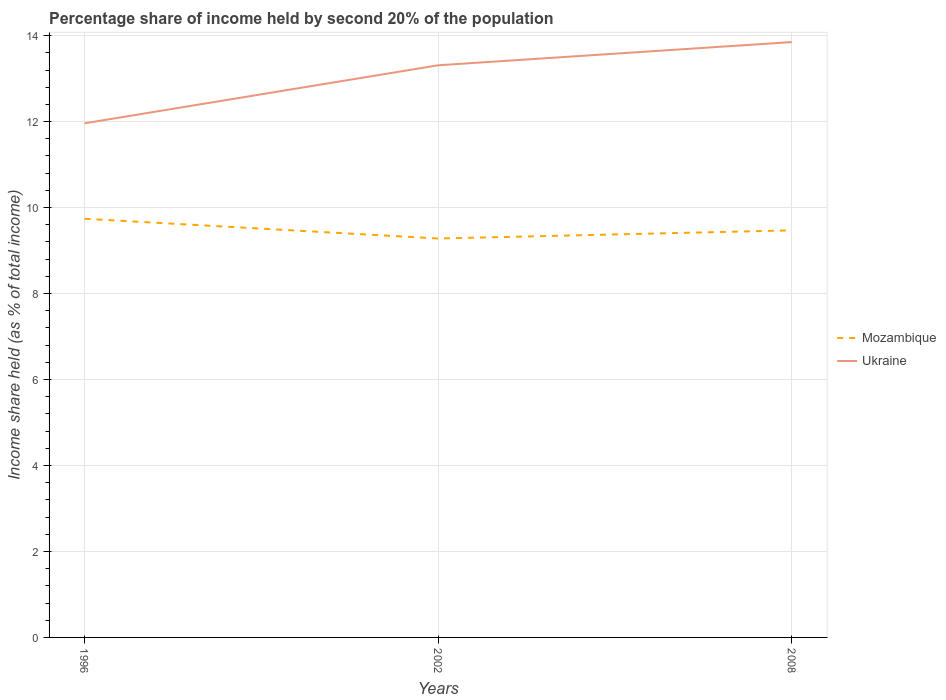How many different coloured lines are there?
Give a very brief answer. 2. Does the line corresponding to Ukraine intersect with the line corresponding to Mozambique?
Give a very brief answer. No. Is the number of lines equal to the number of legend labels?
Your response must be concise. Yes. Across all years, what is the maximum share of income held by second 20% of the population in Ukraine?
Offer a very short reply. 11.96. What is the total share of income held by second 20% of the population in Mozambique in the graph?
Keep it short and to the point. 0.46. What is the difference between the highest and the second highest share of income held by second 20% of the population in Mozambique?
Give a very brief answer. 0.46. How many lines are there?
Ensure brevity in your answer.  2. What is the difference between two consecutive major ticks on the Y-axis?
Your answer should be very brief. 2. Does the graph contain grids?
Offer a terse response. Yes. How many legend labels are there?
Your answer should be compact. 2. What is the title of the graph?
Offer a very short reply. Percentage share of income held by second 20% of the population. What is the label or title of the X-axis?
Give a very brief answer. Years. What is the label or title of the Y-axis?
Your response must be concise. Income share held (as % of total income). What is the Income share held (as % of total income) in Mozambique in 1996?
Keep it short and to the point. 9.74. What is the Income share held (as % of total income) in Ukraine in 1996?
Offer a very short reply. 11.96. What is the Income share held (as % of total income) of Mozambique in 2002?
Ensure brevity in your answer.  9.28. What is the Income share held (as % of total income) of Ukraine in 2002?
Give a very brief answer. 13.31. What is the Income share held (as % of total income) in Mozambique in 2008?
Make the answer very short. 9.47. What is the Income share held (as % of total income) in Ukraine in 2008?
Keep it short and to the point. 13.85. Across all years, what is the maximum Income share held (as % of total income) of Mozambique?
Provide a short and direct response. 9.74. Across all years, what is the maximum Income share held (as % of total income) of Ukraine?
Your answer should be very brief. 13.85. Across all years, what is the minimum Income share held (as % of total income) in Mozambique?
Your answer should be compact. 9.28. Across all years, what is the minimum Income share held (as % of total income) in Ukraine?
Your response must be concise. 11.96. What is the total Income share held (as % of total income) in Mozambique in the graph?
Give a very brief answer. 28.49. What is the total Income share held (as % of total income) of Ukraine in the graph?
Provide a succinct answer. 39.12. What is the difference between the Income share held (as % of total income) in Mozambique in 1996 and that in 2002?
Offer a very short reply. 0.46. What is the difference between the Income share held (as % of total income) in Ukraine in 1996 and that in 2002?
Offer a very short reply. -1.35. What is the difference between the Income share held (as % of total income) in Mozambique in 1996 and that in 2008?
Provide a short and direct response. 0.27. What is the difference between the Income share held (as % of total income) of Ukraine in 1996 and that in 2008?
Provide a succinct answer. -1.89. What is the difference between the Income share held (as % of total income) of Mozambique in 2002 and that in 2008?
Your response must be concise. -0.19. What is the difference between the Income share held (as % of total income) in Ukraine in 2002 and that in 2008?
Provide a short and direct response. -0.54. What is the difference between the Income share held (as % of total income) in Mozambique in 1996 and the Income share held (as % of total income) in Ukraine in 2002?
Make the answer very short. -3.57. What is the difference between the Income share held (as % of total income) of Mozambique in 1996 and the Income share held (as % of total income) of Ukraine in 2008?
Give a very brief answer. -4.11. What is the difference between the Income share held (as % of total income) in Mozambique in 2002 and the Income share held (as % of total income) in Ukraine in 2008?
Your answer should be very brief. -4.57. What is the average Income share held (as % of total income) in Mozambique per year?
Give a very brief answer. 9.5. What is the average Income share held (as % of total income) in Ukraine per year?
Give a very brief answer. 13.04. In the year 1996, what is the difference between the Income share held (as % of total income) in Mozambique and Income share held (as % of total income) in Ukraine?
Offer a very short reply. -2.22. In the year 2002, what is the difference between the Income share held (as % of total income) in Mozambique and Income share held (as % of total income) in Ukraine?
Ensure brevity in your answer.  -4.03. In the year 2008, what is the difference between the Income share held (as % of total income) in Mozambique and Income share held (as % of total income) in Ukraine?
Your answer should be very brief. -4.38. What is the ratio of the Income share held (as % of total income) of Mozambique in 1996 to that in 2002?
Provide a short and direct response. 1.05. What is the ratio of the Income share held (as % of total income) of Ukraine in 1996 to that in 2002?
Keep it short and to the point. 0.9. What is the ratio of the Income share held (as % of total income) of Mozambique in 1996 to that in 2008?
Give a very brief answer. 1.03. What is the ratio of the Income share held (as % of total income) in Ukraine in 1996 to that in 2008?
Ensure brevity in your answer.  0.86. What is the ratio of the Income share held (as % of total income) in Mozambique in 2002 to that in 2008?
Give a very brief answer. 0.98. What is the ratio of the Income share held (as % of total income) in Ukraine in 2002 to that in 2008?
Offer a terse response. 0.96. What is the difference between the highest and the second highest Income share held (as % of total income) in Mozambique?
Your answer should be very brief. 0.27. What is the difference between the highest and the second highest Income share held (as % of total income) of Ukraine?
Your response must be concise. 0.54. What is the difference between the highest and the lowest Income share held (as % of total income) of Mozambique?
Your answer should be very brief. 0.46. What is the difference between the highest and the lowest Income share held (as % of total income) in Ukraine?
Your response must be concise. 1.89. 